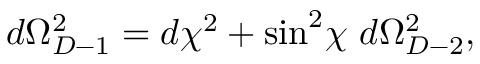<formula> <loc_0><loc_0><loc_500><loc_500>d \Omega _ { D - 1 } ^ { 2 } = d \chi ^ { 2 } + \sin ^ { 2 } \, \chi d \Omega _ { D - 2 } ^ { 2 } ,</formula> 